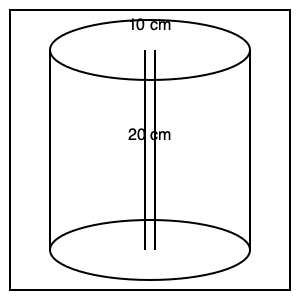The retired baker uses a cylindrical mixing bowl to make pancake batter. The bowl has a radius of 10 cm and a height of 20 cm. What is the volume of pancake batter that can fit in this mixing bowl? To find the volume of the cylindrical mixing bowl, we need to use the formula for the volume of a cylinder:

$$V = \pi r^2 h$$

Where:
$V$ = volume
$\pi$ = pi (approximately 3.14159)
$r$ = radius of the base
$h$ = height of the cylinder

Given:
- Radius $(r) = 10$ cm
- Height $(h) = 20$ cm

Let's substitute these values into the formula:

$$V = \pi (10 \text{ cm})^2 (20 \text{ cm})$$

$$V = \pi (100 \text{ cm}^2) (20 \text{ cm})$$

$$V = 2000\pi \text{ cm}^3$$

Now, let's calculate the approximate value:

$$V \approx 2000 \times 3.14159 \text{ cm}^3$$

$$V \approx 6283.18 \text{ cm}^3$$

Rounding to the nearest whole number:

$$V \approx 6283 \text{ cm}^3$$

Therefore, the mixing bowl can hold approximately 6283 cubic centimeters of pancake batter.
Answer: 6283 cm³ 